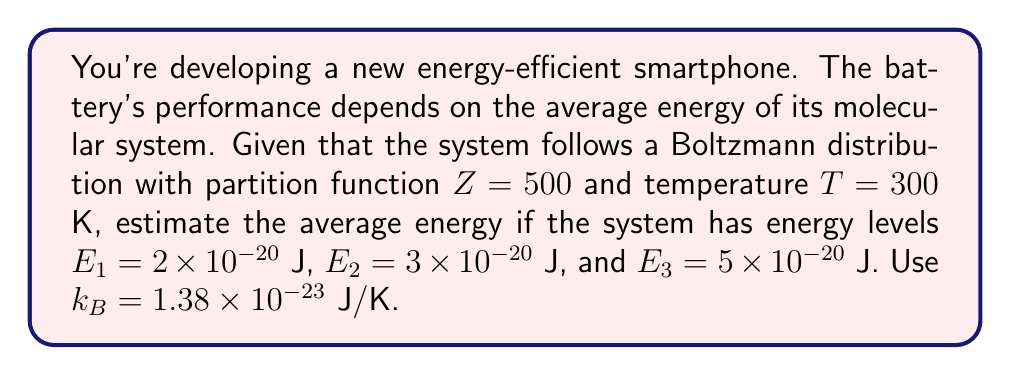Provide a solution to this math problem. 1. The average energy $\langle E \rangle$ using the Boltzmann distribution is given by:

   $$\langle E \rangle = -\frac{\partial \ln Z}{\partial \beta}$$

   where $\beta = \frac{1}{k_B T}$

2. We need to express $Z$ in terms of $\beta$:

   $$Z = \sum_i e^{-\beta E_i} = e^{-\beta E_1} + e^{-\beta E_2} + e^{-\beta E_3}$$

3. Calculate $\beta$:

   $$\beta = \frac{1}{k_B T} = \frac{1}{(1.38 \times 10^{-23})(300)} = 2.415 \times 10^{20} \text{ J}^{-1}$$

4. Now, we can calculate $\langle E \rangle$:

   $$\langle E \rangle = \frac{E_1 e^{-\beta E_1} + E_2 e^{-\beta E_2} + E_3 e^{-\beta E_3}}{Z}$$

5. Substitute the values:

   $$\langle E \rangle = \frac{(2 \times 10^{-20})e^{-(2.415 \times 10^{20})(2 \times 10^{-20})} + (3 \times 10^{-20})e^{-(2.415 \times 10^{20})(3 \times 10^{-20})} + (5 \times 10^{-20})e^{-(2.415 \times 10^{20})(5 \times 10^{-20})}}{500}$$

6. Simplify:

   $$\langle E \rangle = \frac{(2 \times 10^{-20})e^{-4.83} + (3 \times 10^{-20})e^{-7.245} + (5 \times 10^{-20})e^{-12.075}}{500}$$

7. Calculate:

   $$\langle E \rangle \approx 2.13 \times 10^{-22} \text{ J}$$
Answer: $2.13 \times 10^{-22}$ J 